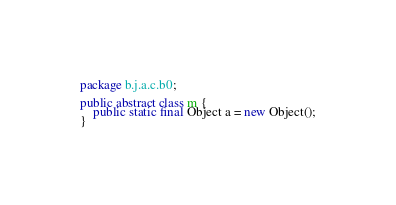<code> <loc_0><loc_0><loc_500><loc_500><_Java_>package b.j.a.c.b0;

public abstract class m {
    public static final Object a = new Object();
}
</code> 